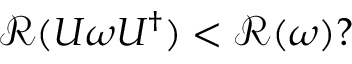Convert formula to latex. <formula><loc_0><loc_0><loc_500><loc_500>\begin{array} { r } { \mathcal { R } ( U \omega U ^ { \dagger } ) < \mathcal { R } ( \omega ) ? } \end{array}</formula> 